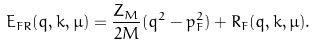Convert formula to latex. <formula><loc_0><loc_0><loc_500><loc_500>E _ { F R } ( q , k , \mu ) = \frac { Z _ { M } } { 2 M } ( q ^ { 2 } - p _ { F } ^ { 2 } ) + R _ { F } ( q , k , \mu ) .</formula> 